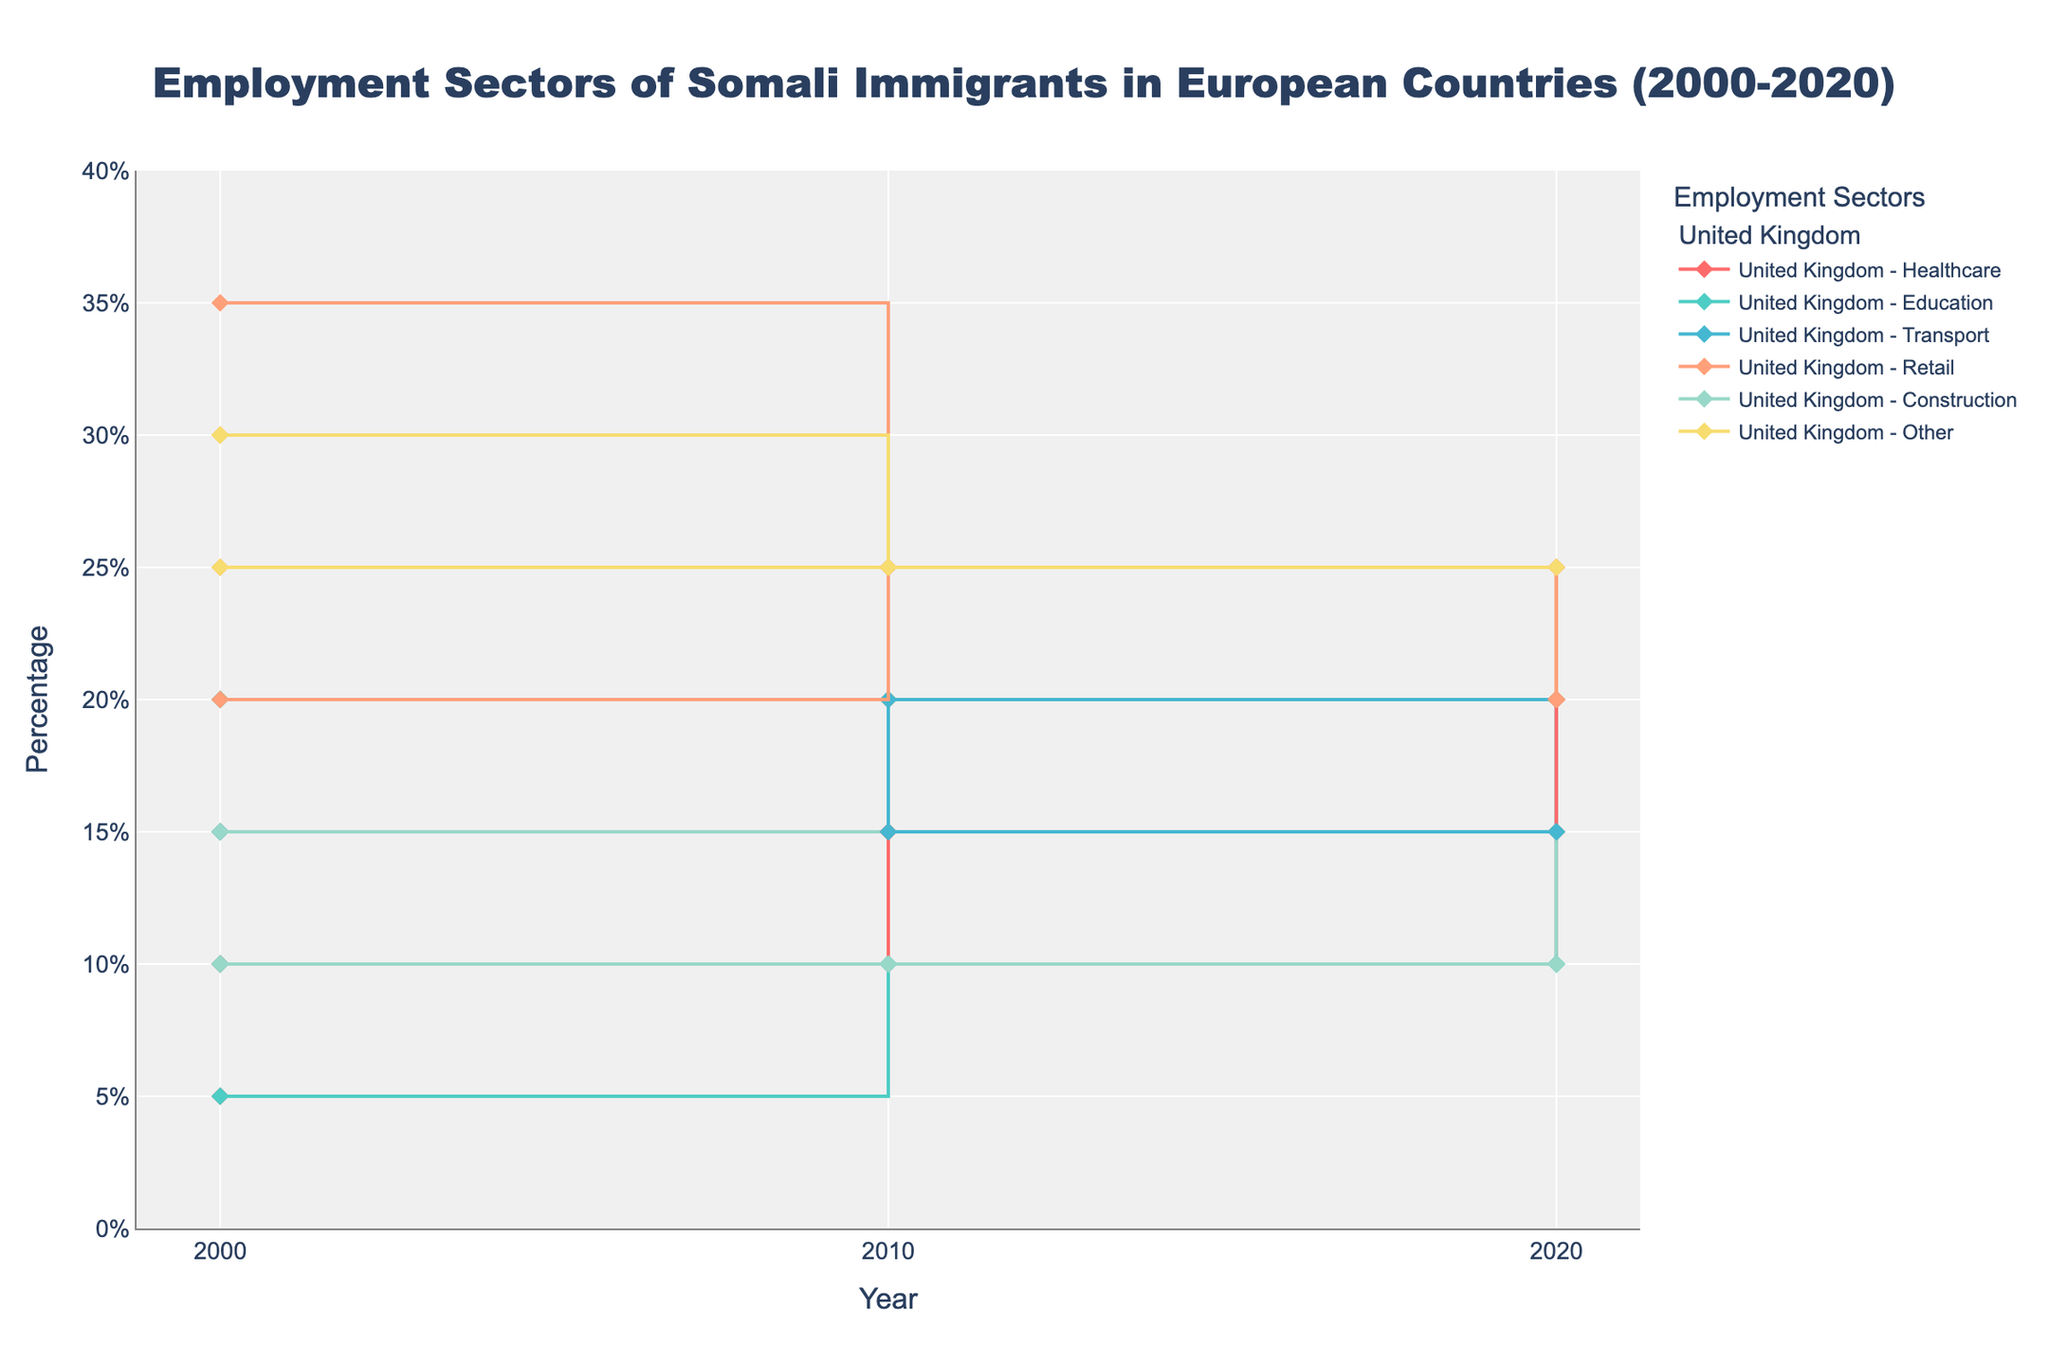What is the title of the figure? The title is located at the top of the figure, generally in a larger and bold font.
Answer: Employment Sectors of Somali Immigrants in European Countries (2000-2020) What is the y-axis title and its unit? The y-axis title is generally located below or to the side of the y-axis. The unit is often indicated next to the title.
Answer: Percentage (%) Which country had the highest percentage of Somali immigrants in the Retail sector in 2000? Look for the percentage values of the Retail sector for each country in 2000 and identify the highest one.
Answer: Germany How did the percentage of Somali immigrants in the Healthcare sector change in the United Kingdom from 2000 to 2020? Observe the y-values for the Healthcare sector in the United Kingdom for the years 2000 and 2020. Note the difference.
Answer: Increased from 15% to 25% What was the percentage of Somali immigrants working in the Education sector in Sweden in 2010? Look for the y-value corresponding to the Education sector in Sweden in 2010.
Answer: 10% Compare the percentage of Somali immigrants in the Transport sector in Sweden and Germany in 2020. Which country had a higher percentage? Identify the y-values for the Transport sector in both Sweden and Germany for 2020, then compare them.
Answer: Germany Which employment sector experienced the most significant increase in percentage in the Netherlands from 2000 to 2010? Compute the differences in percentage for each sector between 2000 and 2010, then identify the largest increase.
Answer: Retail (from 20% to 25%) How did the percentage of Somali immigrants in the Retail sector in Sweden change between 2000 and 2020? Observe the percentage values for the Retail sector in Sweden for the years 2000 and 2020, and note the difference.
Answer: Decreased from 30% to 20% In 2020, which country had the highest percentage of Somali immigrants working in the Construction sector? Identify the percentage values for the Construction sector in each country for 2020, and find the highest one.
Answer: Sweden What trends can be observed in the Employment sector for Somali immigrants in the Netherlands between 2000 and 2020? Review the trends (increase, decrease, stability) for the employment sectors in the Netherlands from the data provided for 2000, 2010, and 2020.
Answer: Healthcare increased, Education remained stable, Transport decreased, Retail remained stable, Construction remained stable, Other decreased 